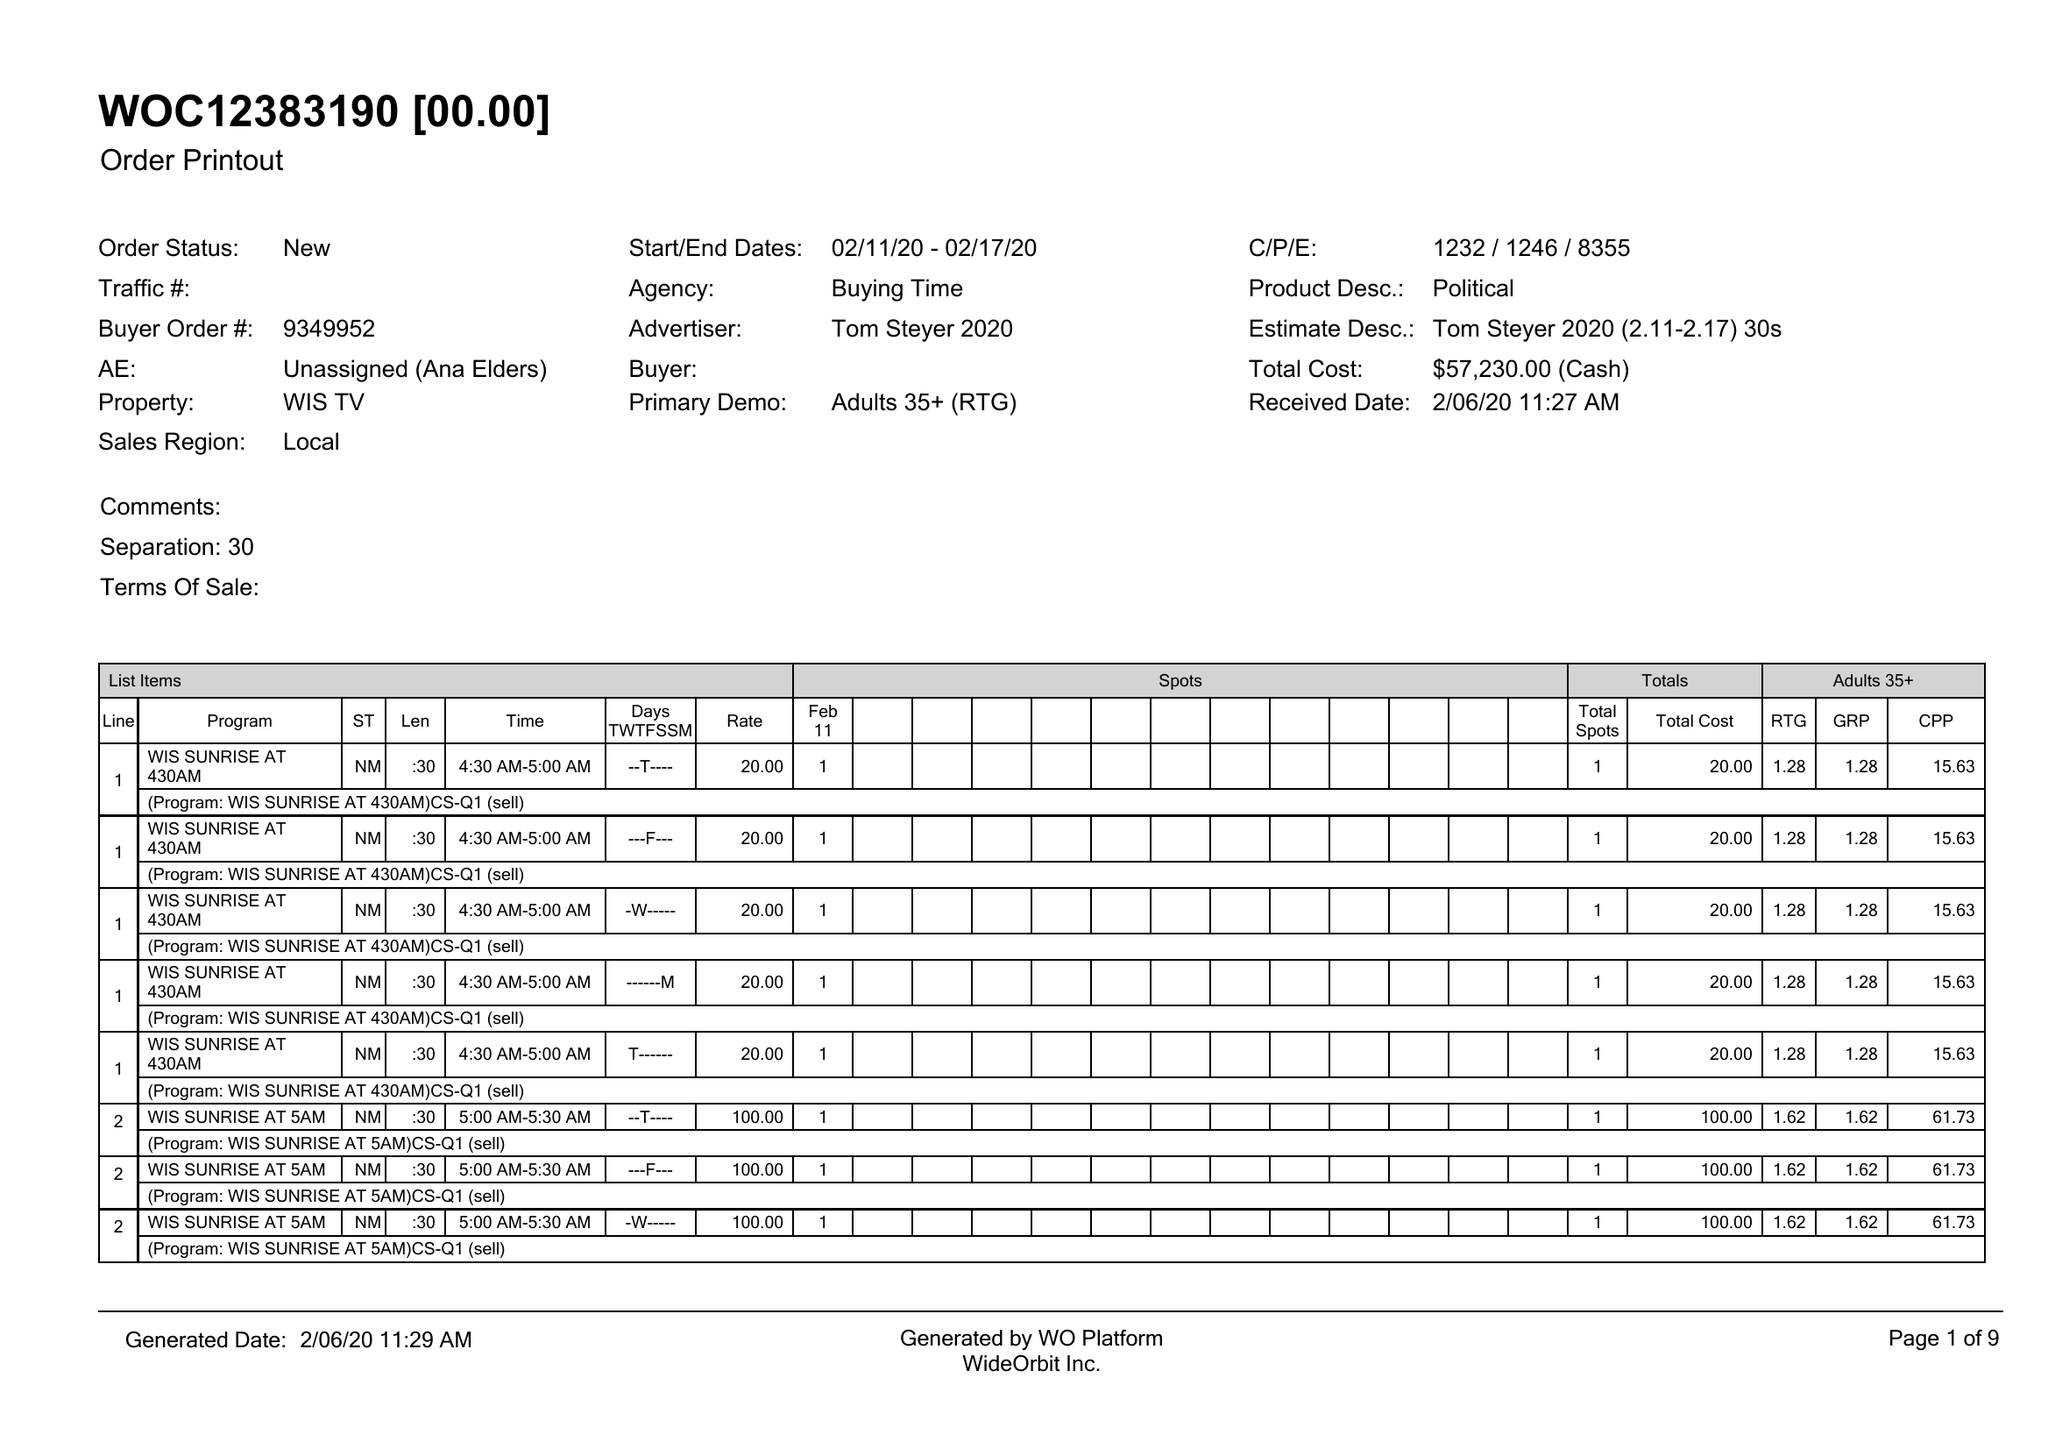What is the value for the contract_num?
Answer the question using a single word or phrase. 9349952 